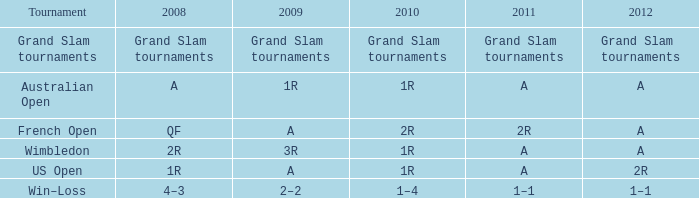What is the contest during 2011 with a 2r round? French Open. 